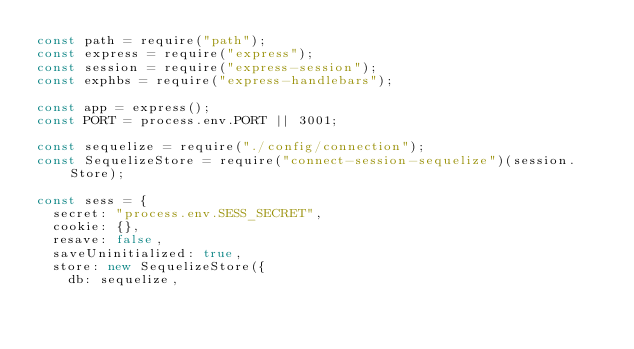<code> <loc_0><loc_0><loc_500><loc_500><_JavaScript_>const path = require("path");
const express = require("express");
const session = require("express-session");
const exphbs = require("express-handlebars");

const app = express();
const PORT = process.env.PORT || 3001;

const sequelize = require("./config/connection");
const SequelizeStore = require("connect-session-sequelize")(session.Store);

const sess = {
  secret: "process.env.SESS_SECRET",
  cookie: {},
  resave: false,
  saveUninitialized: true,
  store: new SequelizeStore({
    db: sequelize,</code> 